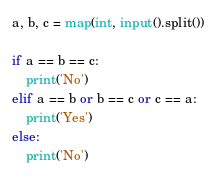Convert code to text. <code><loc_0><loc_0><loc_500><loc_500><_Python_>a, b, c = map(int, input().split())

if a == b == c:
    print('No')
elif a == b or b == c or c == a:
    print('Yes')
else:
    print('No')
</code> 